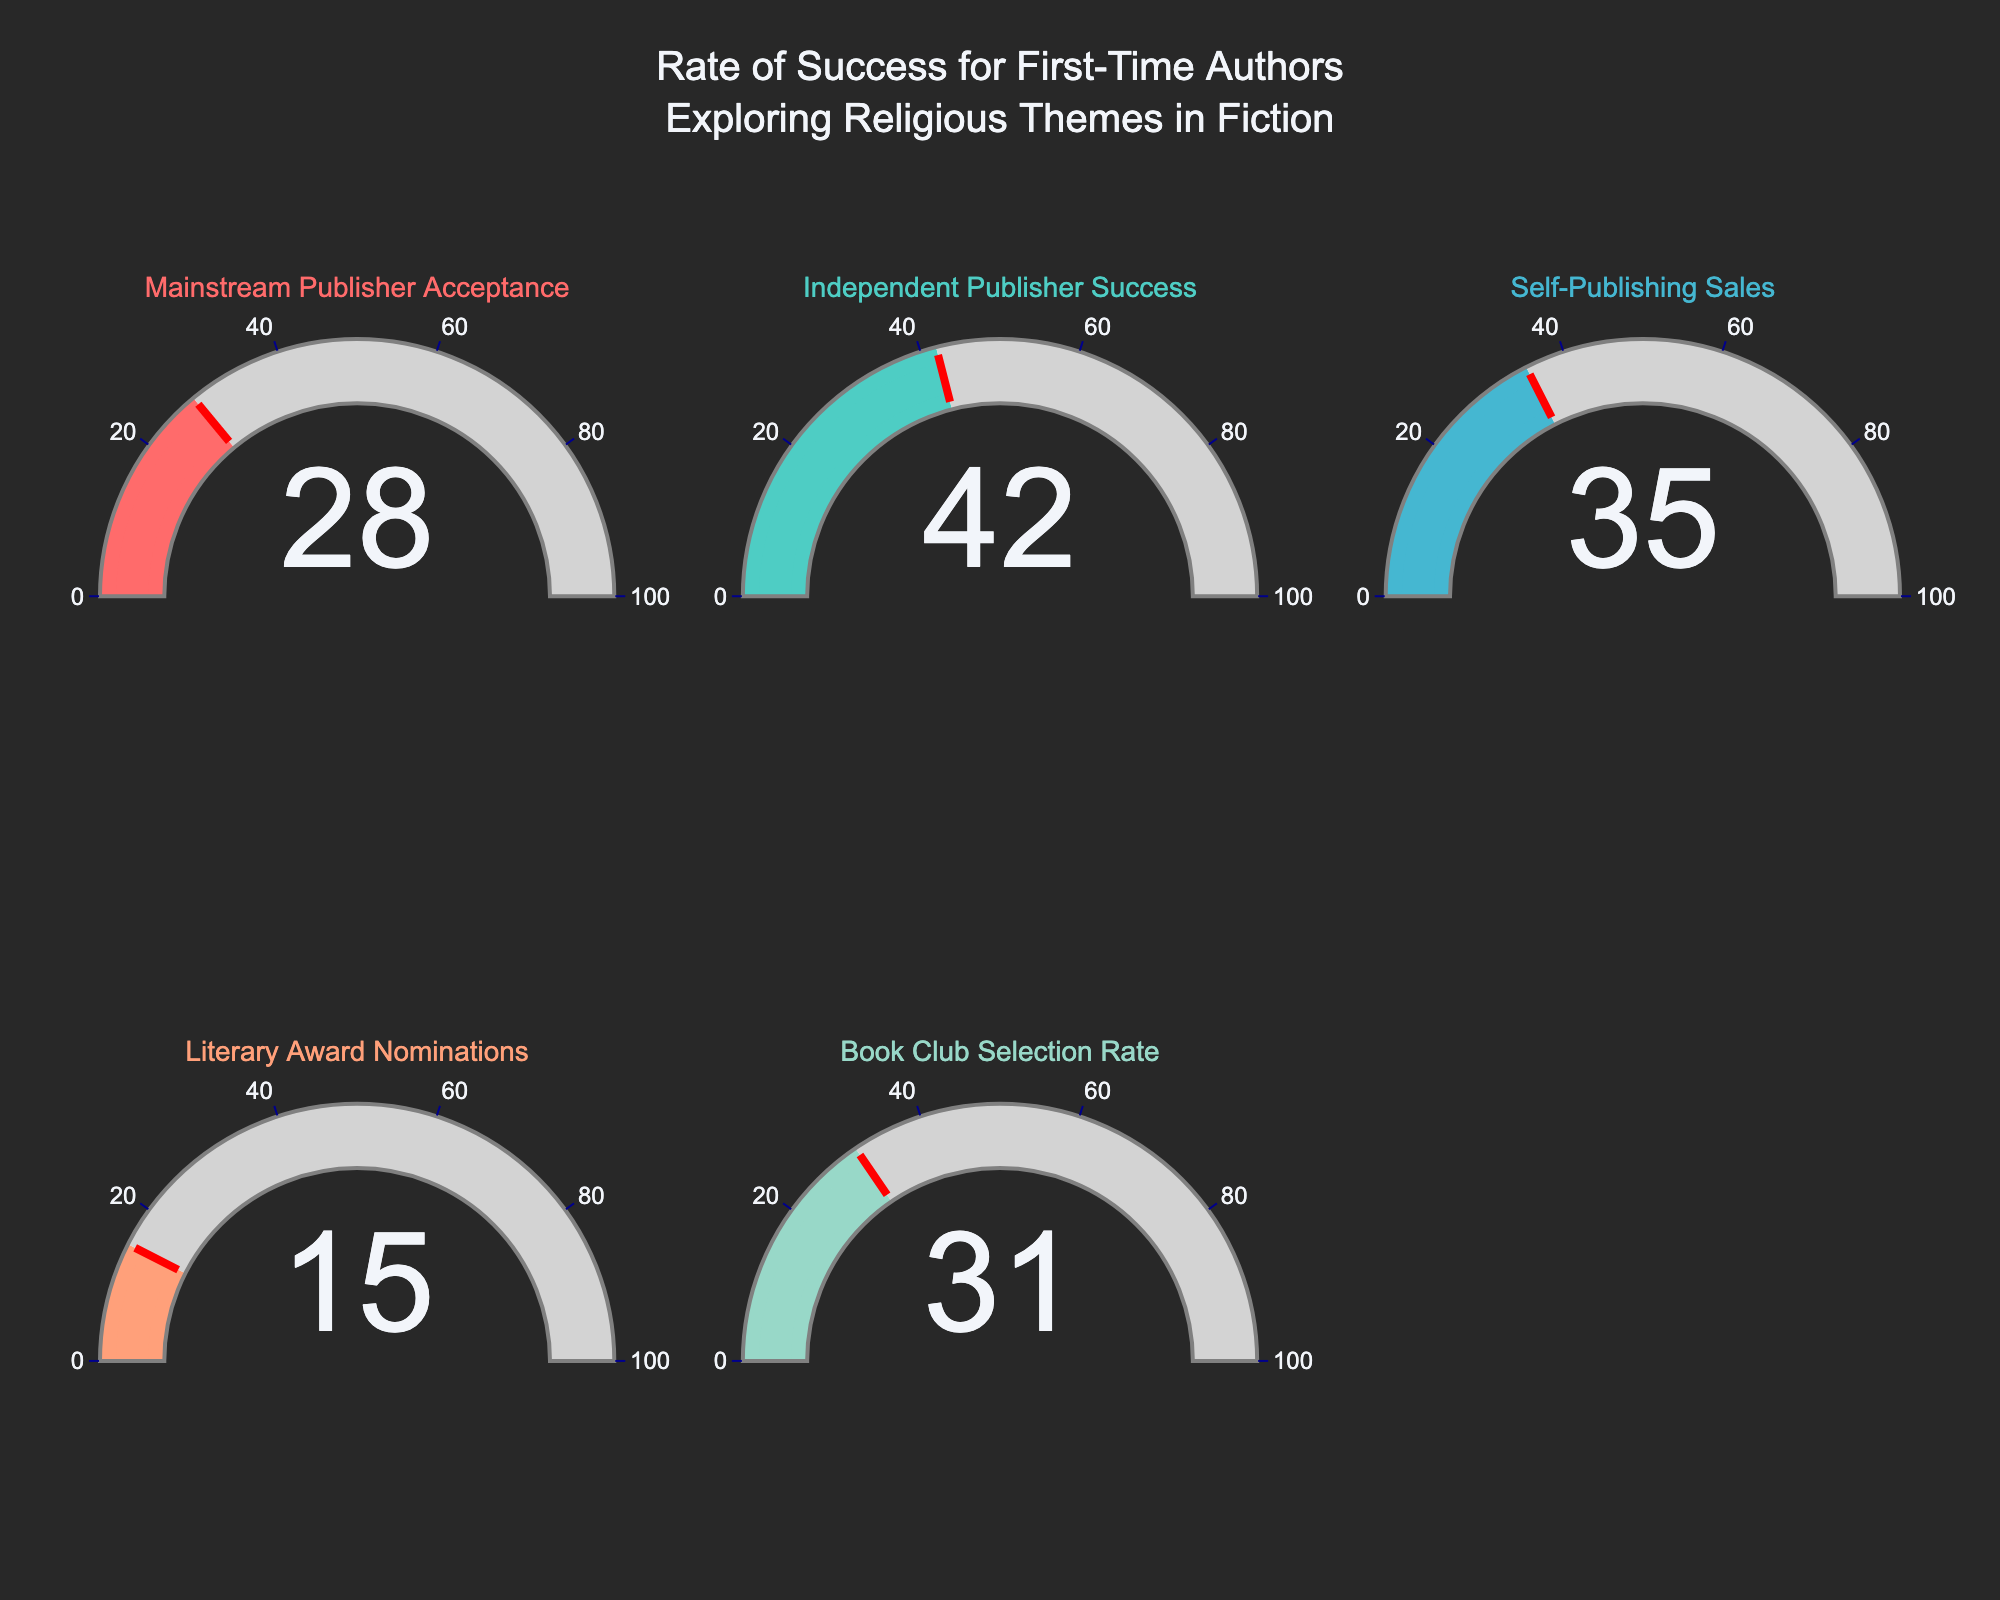What is the highest rate of success for first-time authors in any category? To find the highest rate of success, look at the values displayed on each gauge. The highest value is 42, which corresponds to "Independent Publisher Success".
Answer: 42 How much higher is the "Independent Publisher Success" rate compared to the "Literary Award Nominations" rate? The "Independent Publisher Success" rate is 42 and the "Literary Award Nominations" rate is 15. Subtract 15 from 42 to find the difference: 42 - 15 = 27.
Answer: 27 Which category has the lowest rate of success? Look at the values on the gauges to determine the lowest. The lowest value is 15 for "Literary Award Nominations".
Answer: Literary Award Nominations What is the average rate of success for all the categories? Add up all the values and divide by the number of categories: (28 + 42 + 35 + 15 + 31) / 5 = 30.2.
Answer: 30.2 What is the difference between the "Self-Publishing Sales" and "Book Club Selection Rate" success rates? The "Self-Publishing Sales" rate is 35 and the "Book Club Selection Rate" is 31. Subtract the smaller value from the larger one: 35 - 31 = 4.
Answer: 4 Which two categories have the closest success rates, and what are those rates? Compare each rate to find the closest pair. "Self-Publishing Sales" is 35 and "Book Club Selection Rate" is 31. The difference is 4, which is the smallest difference among the pairs.
Answer: Self-Publishing Sales (35) and Book Club Selection Rate (31) What percentage of the "Mainstream Publisher Acceptance" rate is the "Literary Award Nominations" rate? Divide the "Literary Award Nominations" rate by the "Mainstream Publisher Acceptance" rate and multiply by 100: (15 / 28) * 100 ≈ 53.57%.
Answer: ~53.57% How many categories have a success rate above 30? Count the categories with values above 30: "Independent Publisher Success" (42), "Self-Publishing Sales" (35), and "Book Club Selection Rate" (31) are all above 30, totaling 3 categories.
Answer: 3 